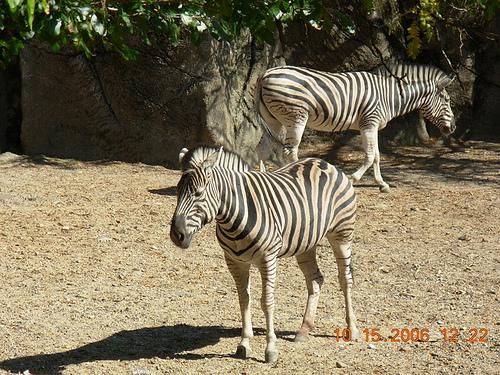How many zebras are there?
Write a very short answer. 2. Is this a picture of zebra in their natural habitat?
Answer briefly. No. Is the zebra happy?
Quick response, please. No. How many zebras are in the image?
Write a very short answer. 2. How many zebra feet are there?
Concise answer only. 8. 